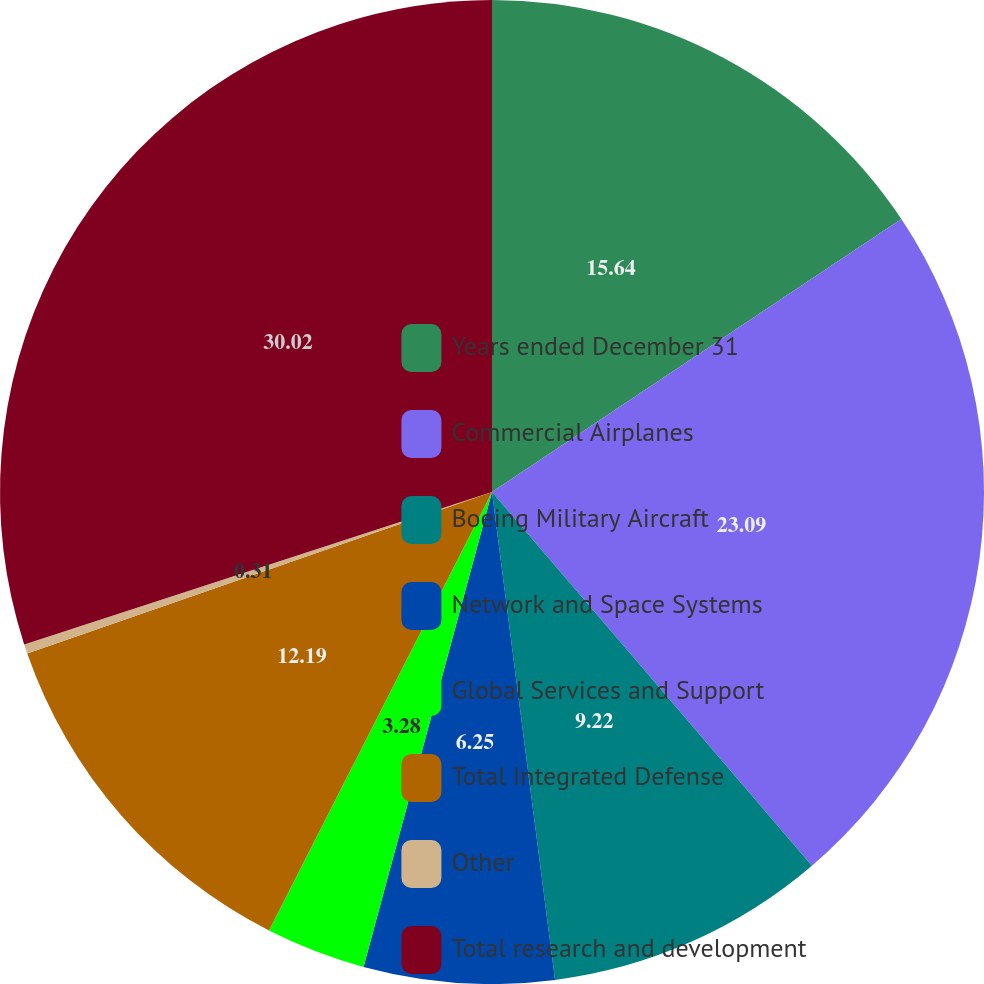Convert chart. <chart><loc_0><loc_0><loc_500><loc_500><pie_chart><fcel>Years ended December 31<fcel>Commercial Airplanes<fcel>Boeing Military Aircraft<fcel>Network and Space Systems<fcel>Global Services and Support<fcel>Total Integrated Defense<fcel>Other<fcel>Total research and development<nl><fcel>15.64%<fcel>23.09%<fcel>9.22%<fcel>6.25%<fcel>3.28%<fcel>12.19%<fcel>0.31%<fcel>30.01%<nl></chart> 